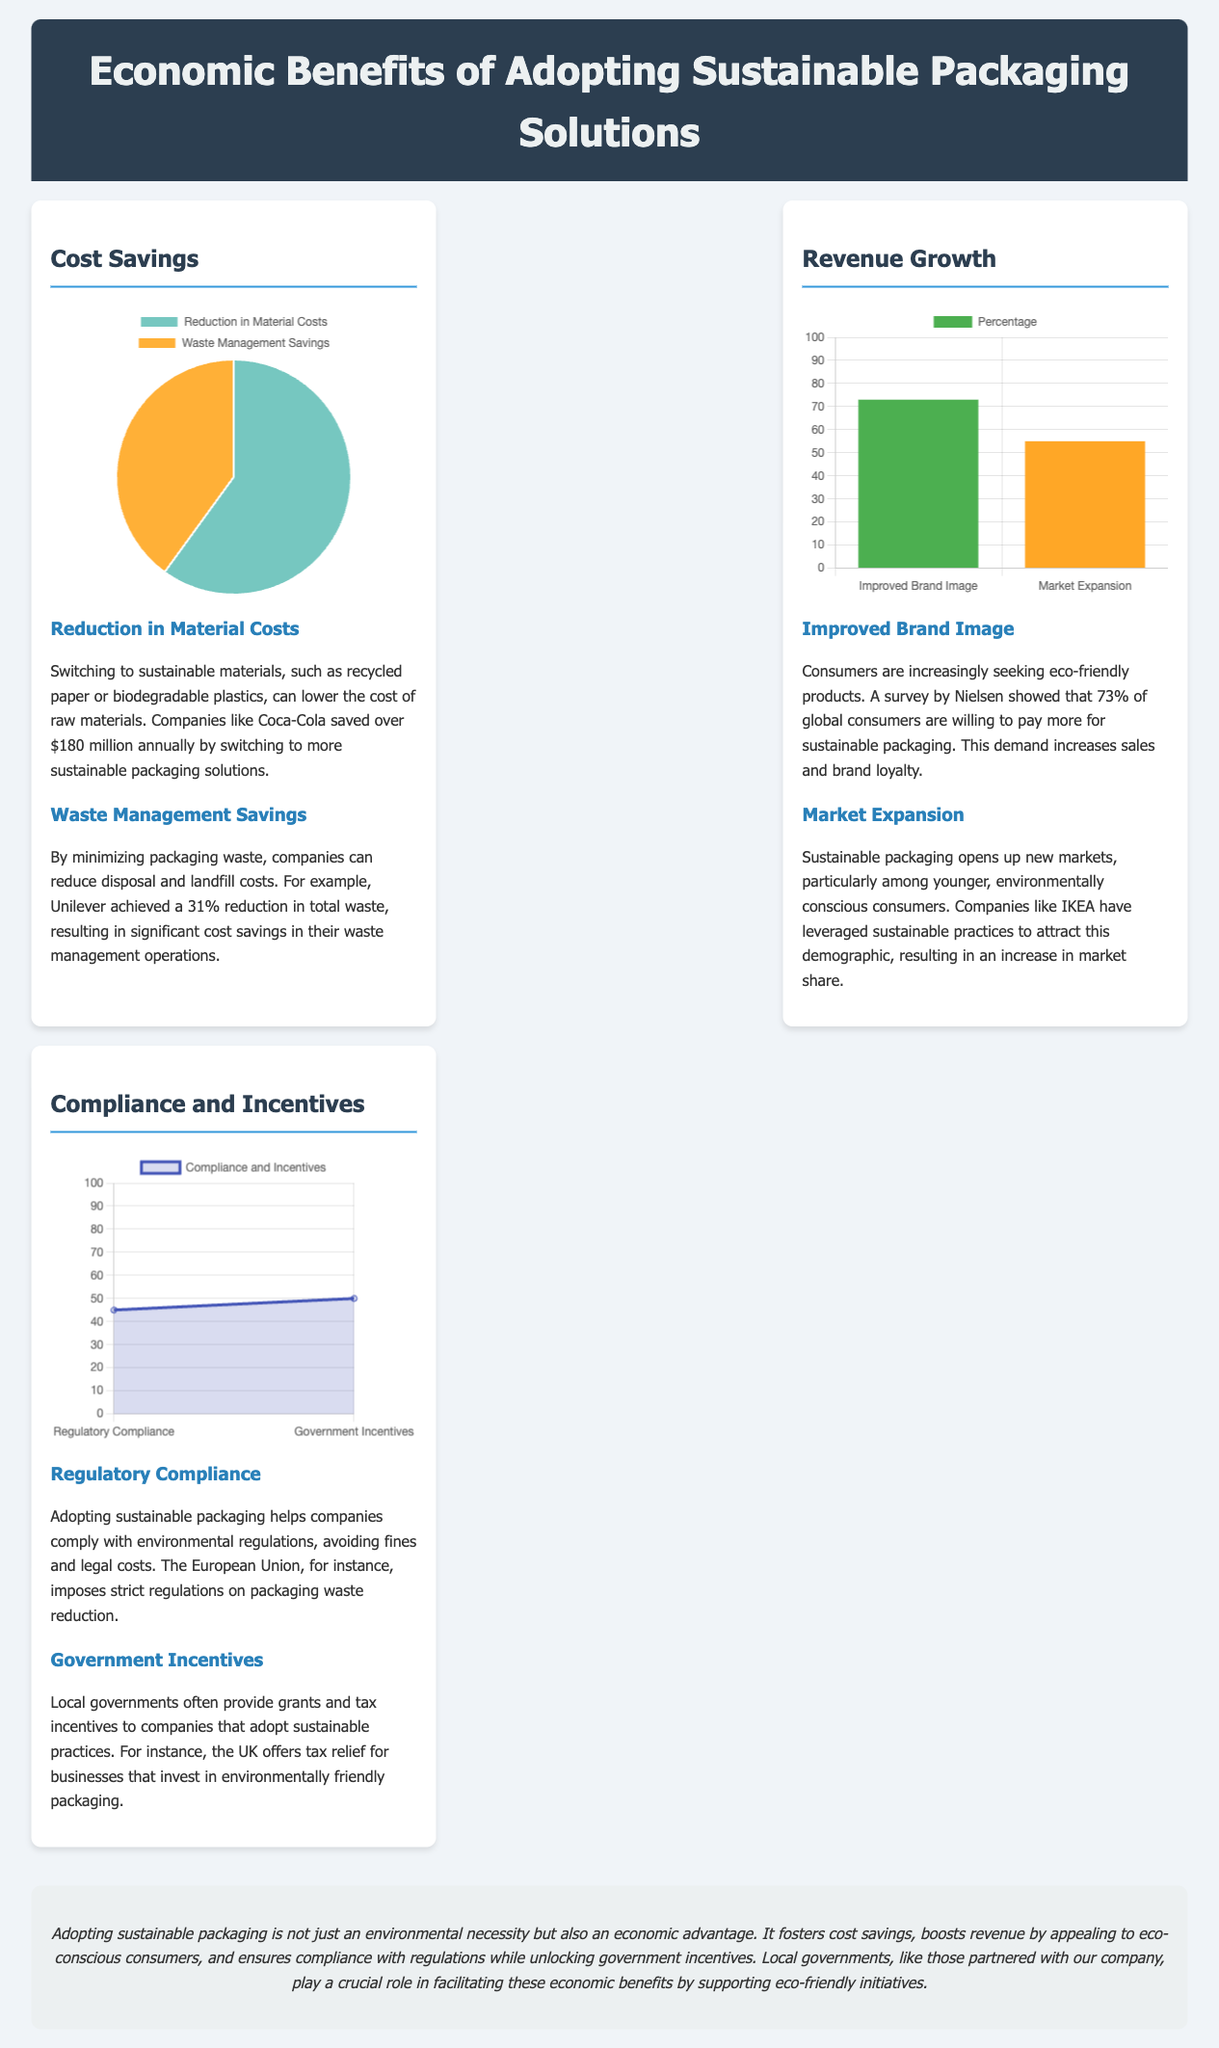what is the title of the document? The title is prominently displayed at the top of the document under the header section.
Answer: Economic Benefits of Adopting Sustainable Packaging Solutions how much did Coca-Cola save by switching to sustainable packaging? The document states that Coca-Cola saved over $180 million annually by switching to more sustainable packaging solutions.
Answer: $180 million what percentage of global consumers are willing to pay more for sustainable packaging? According to a survey by Nielsen mentioned in the document, 73% of global consumers are willing to pay more.
Answer: 73% what is the percentage reduction in total waste achieved by Unilever? The document reports a 31% reduction in total waste achieved by Unilever as a result of sustainable practices.
Answer: 31% which factor contributes the highest to revenue growth? The revenue growth factors chart indicates that 'Improved Brand Image' contributes the highest at 73%.
Answer: Improved Brand Image which chart type is used to represent cost savings distribution? The cost savings distribution is represented using a pie chart as indicated in the coding details.
Answer: pie what are the two categories displayed in the Compliance and Incentives chart? The two categories represented in the compliance chart are 'Regulatory Compliance' and 'Government Incentives.'
Answer: Regulatory Compliance, Government Incentives what is the lower percentage value in the Revenue Growth chart? The lower percentage shown in the Revenue Growth chart is for 'Market Expansion', which is 55%.
Answer: 55% what is the overall summary message of the document? The summary message emphasizes the economic advantages of adopting sustainable packaging, including cost savings and increased revenue.
Answer: Economic advantage 